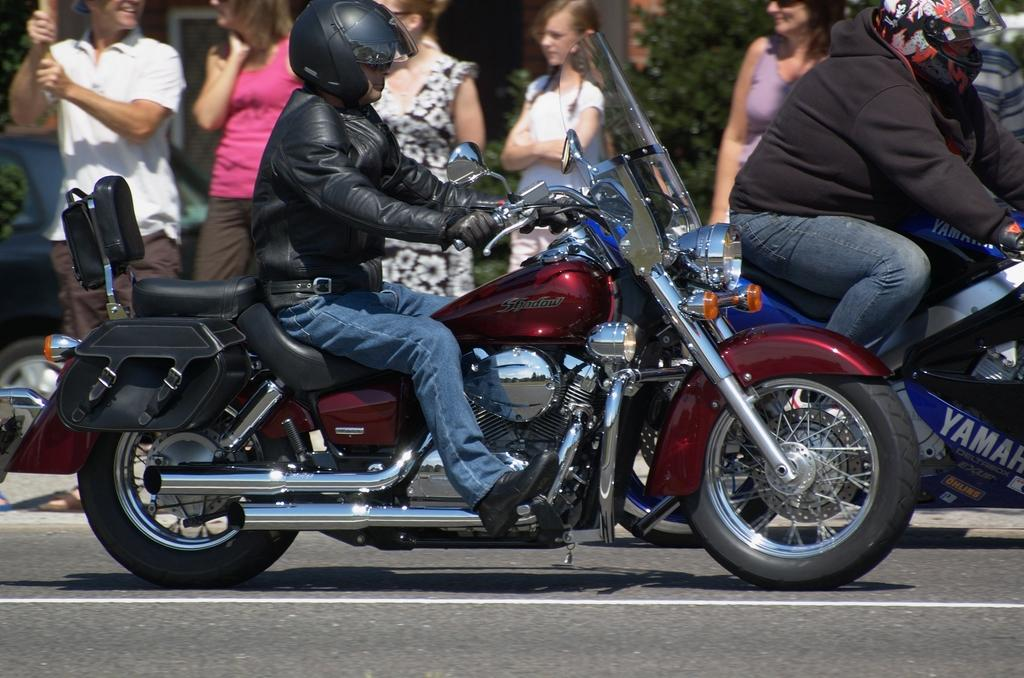What is the main subject of the image? There is a man in the image. What is the man doing in the image? The man is riding a bike. Can you describe the background of the image? There are people standing in the background of the image. What type of flight can be seen in the image? There is no flight visible in the image; it features a man riding a bike. How many clocks are present in the image? There is no mention of clocks in the image; it only shows a man riding a bike and people standing in the background. 